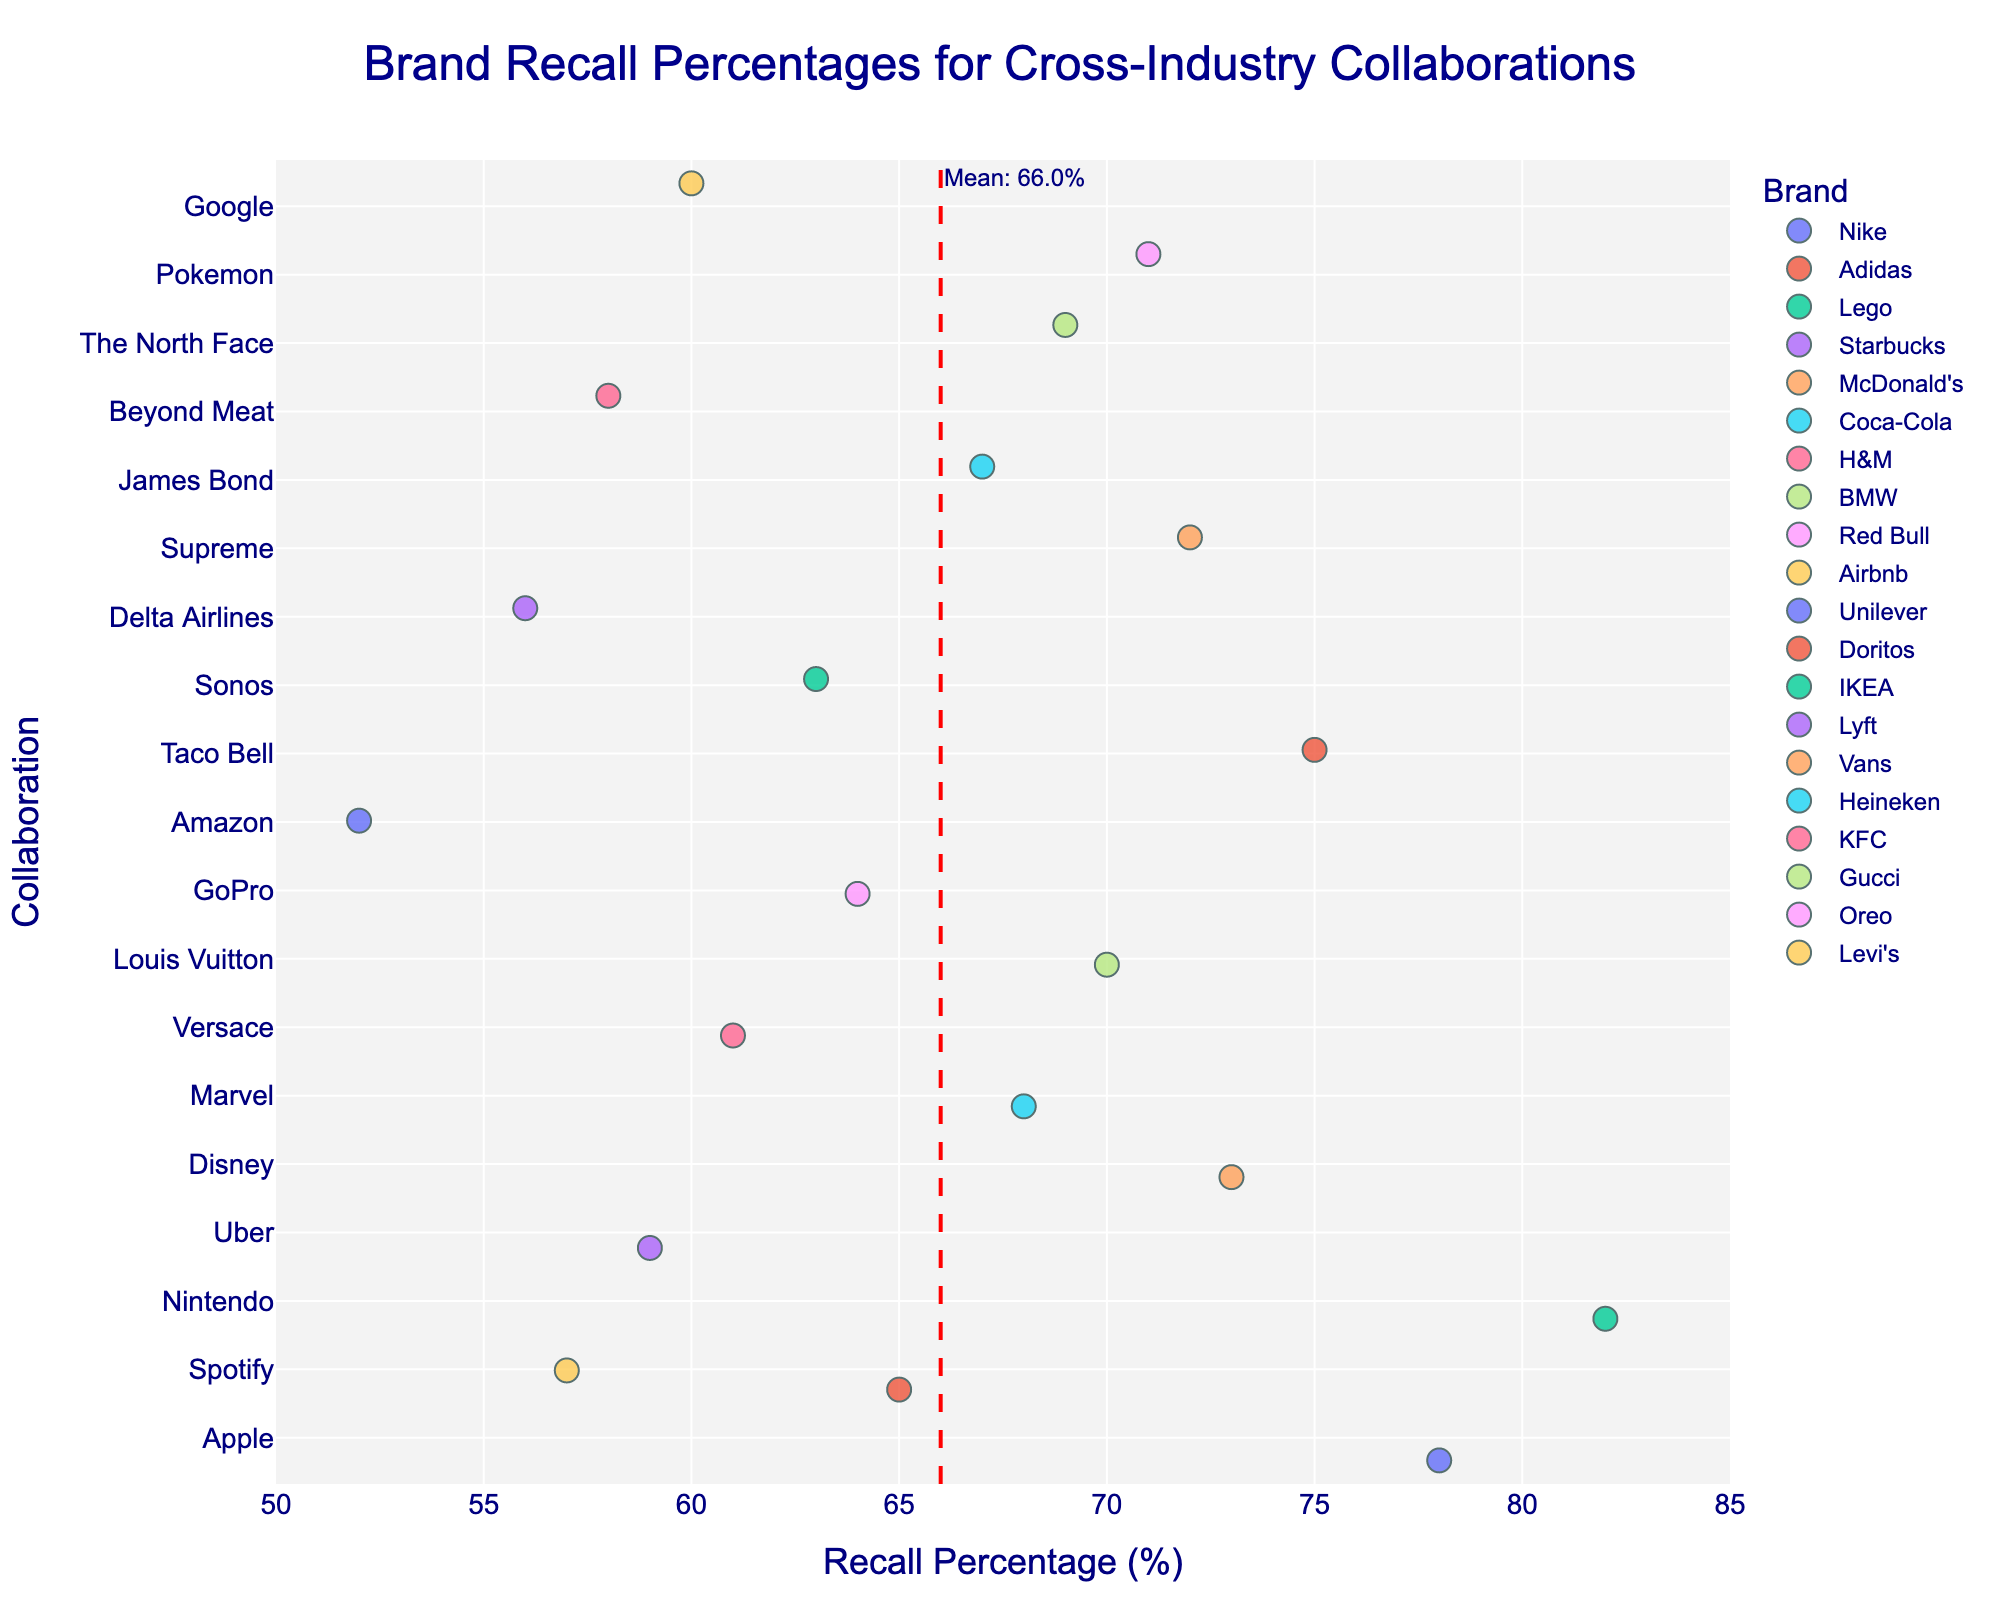What's the title of the figure? The title of the figure is located at the top center of the plot and is usually styled to stand out. By reading the top area of the plot, we can identify the title clearly.
Answer: Brand Recall Percentages for Cross-Industry Collaborations What is the mean recall percentage indicated by the vertical dashed line? The vertical dashed line represents the mean recall percentage and is annotated near the top of the line.
Answer: 65.8% Which brand collaboration has the highest recall percentage? By observing the rightmost position of the plotted points on the x-axis, we can determine the collaboration with the highest recall percentage.
Answer: Lego and Nintendo Which brand collaboration has the lowest recall percentage? By identifying the leftmost position of the plotted points on the x-axis, we can determine the collaboration with the lowest recall percentage.
Answer: Unilever and Amazon How many collaborations have a recall percentage lower than the mean? Count the number of data points to the left of the dashed mean line. These represent collaborations with a recall percentage lower than the mean.
Answer: 8 Which collaboration involving Spotify has a higher recall percentage? Compare the recall percentages of the two collaborations involving Spotify by looking at their positions on the x-axis. The higher recall percentage is closer to the right side of the plot.
Answer: Adidas and Spotify What is the average recall percentage for brand collaborations Nike and Adidas? Add the recall percentages for Nike and Apple (78) and Adidas and Spotify (65), then divide by the number of pairs (2). (78 + 65) / 2 = 71.5
Answer: 71.5% How much higher is the recall percentage of Lego and Nintendo compared to Starbucks and Uber? Subtract the recall percentage of Starbucks and Uber (59) from the recall percentage of Lego and Nintendo (82) to find the difference. 82 - 59 = 23
Answer: 23 Are there more collaborations with recall percentages above or below 60%? Count the number of points to the right and left of the 60% mark on the x-axis to determine the comparison.
Answer: Above 60% What is the range of recall percentages shown in the figure? Identify the highest (82 for Lego and Nintendo) and the lowest (52 for Unilever and Amazon) recall percentages and calculate the difference. 82 - 52 = 30
Answer: 30 